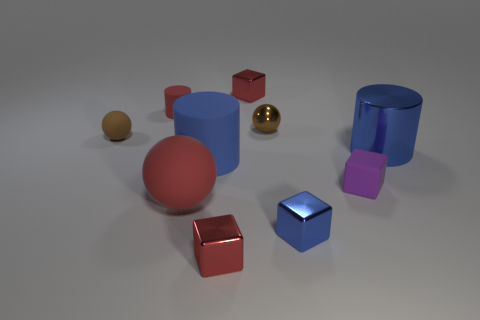Subtract all cubes. How many objects are left? 6 Add 5 metallic cylinders. How many metallic cylinders are left? 6 Add 5 brown spheres. How many brown spheres exist? 7 Subtract all red spheres. How many spheres are left? 2 Subtract all tiny blue metallic blocks. How many blocks are left? 3 Subtract 0 yellow balls. How many objects are left? 10 Subtract 3 cubes. How many cubes are left? 1 Subtract all yellow balls. Subtract all green blocks. How many balls are left? 3 Subtract all blue balls. How many purple cubes are left? 1 Subtract all brown spheres. Subtract all tiny matte objects. How many objects are left? 5 